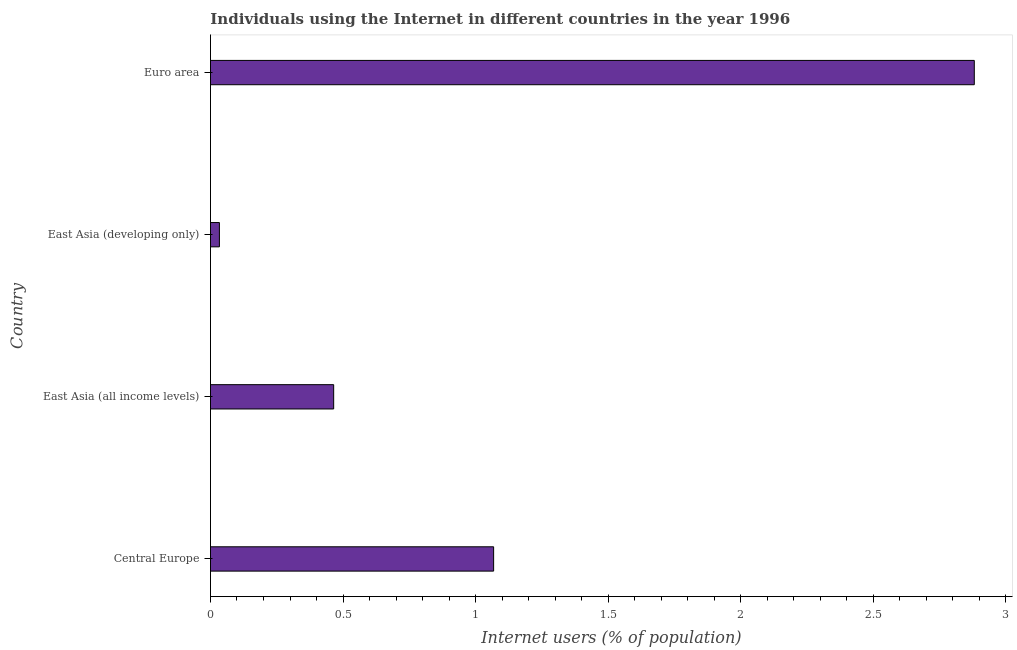What is the title of the graph?
Your answer should be very brief. Individuals using the Internet in different countries in the year 1996. What is the label or title of the X-axis?
Provide a short and direct response. Internet users (% of population). What is the number of internet users in Central Europe?
Offer a very short reply. 1.07. Across all countries, what is the maximum number of internet users?
Your answer should be very brief. 2.88. Across all countries, what is the minimum number of internet users?
Your response must be concise. 0.03. In which country was the number of internet users maximum?
Ensure brevity in your answer.  Euro area. In which country was the number of internet users minimum?
Make the answer very short. East Asia (developing only). What is the sum of the number of internet users?
Provide a short and direct response. 4.45. What is the difference between the number of internet users in Central Europe and Euro area?
Offer a terse response. -1.81. What is the average number of internet users per country?
Make the answer very short. 1.11. What is the median number of internet users?
Offer a terse response. 0.77. In how many countries, is the number of internet users greater than 2.2 %?
Provide a succinct answer. 1. What is the ratio of the number of internet users in Central Europe to that in East Asia (developing only)?
Offer a very short reply. 31.69. Is the difference between the number of internet users in East Asia (all income levels) and East Asia (developing only) greater than the difference between any two countries?
Make the answer very short. No. What is the difference between the highest and the second highest number of internet users?
Your answer should be compact. 1.81. What is the difference between the highest and the lowest number of internet users?
Offer a terse response. 2.85. How many bars are there?
Offer a very short reply. 4. Are all the bars in the graph horizontal?
Keep it short and to the point. Yes. How many countries are there in the graph?
Your answer should be compact. 4. Are the values on the major ticks of X-axis written in scientific E-notation?
Your answer should be very brief. No. What is the Internet users (% of population) of Central Europe?
Your answer should be compact. 1.07. What is the Internet users (% of population) in East Asia (all income levels)?
Your response must be concise. 0.46. What is the Internet users (% of population) of East Asia (developing only)?
Your answer should be very brief. 0.03. What is the Internet users (% of population) in Euro area?
Provide a succinct answer. 2.88. What is the difference between the Internet users (% of population) in Central Europe and East Asia (all income levels)?
Your answer should be very brief. 0.6. What is the difference between the Internet users (% of population) in Central Europe and East Asia (developing only)?
Offer a very short reply. 1.03. What is the difference between the Internet users (% of population) in Central Europe and Euro area?
Your response must be concise. -1.81. What is the difference between the Internet users (% of population) in East Asia (all income levels) and East Asia (developing only)?
Your answer should be compact. 0.43. What is the difference between the Internet users (% of population) in East Asia (all income levels) and Euro area?
Provide a succinct answer. -2.42. What is the difference between the Internet users (% of population) in East Asia (developing only) and Euro area?
Ensure brevity in your answer.  -2.85. What is the ratio of the Internet users (% of population) in Central Europe to that in East Asia (all income levels)?
Make the answer very short. 2.3. What is the ratio of the Internet users (% of population) in Central Europe to that in East Asia (developing only)?
Your answer should be very brief. 31.69. What is the ratio of the Internet users (% of population) in Central Europe to that in Euro area?
Give a very brief answer. 0.37. What is the ratio of the Internet users (% of population) in East Asia (all income levels) to that in East Asia (developing only)?
Your answer should be compact. 13.79. What is the ratio of the Internet users (% of population) in East Asia (all income levels) to that in Euro area?
Ensure brevity in your answer.  0.16. What is the ratio of the Internet users (% of population) in East Asia (developing only) to that in Euro area?
Give a very brief answer. 0.01. 